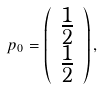Convert formula to latex. <formula><loc_0><loc_0><loc_500><loc_500>p _ { 0 } = \left ( \begin{array} { c } \frac { 1 } { 2 } \\ \frac { 1 } { 2 } \end{array} \right ) ,</formula> 